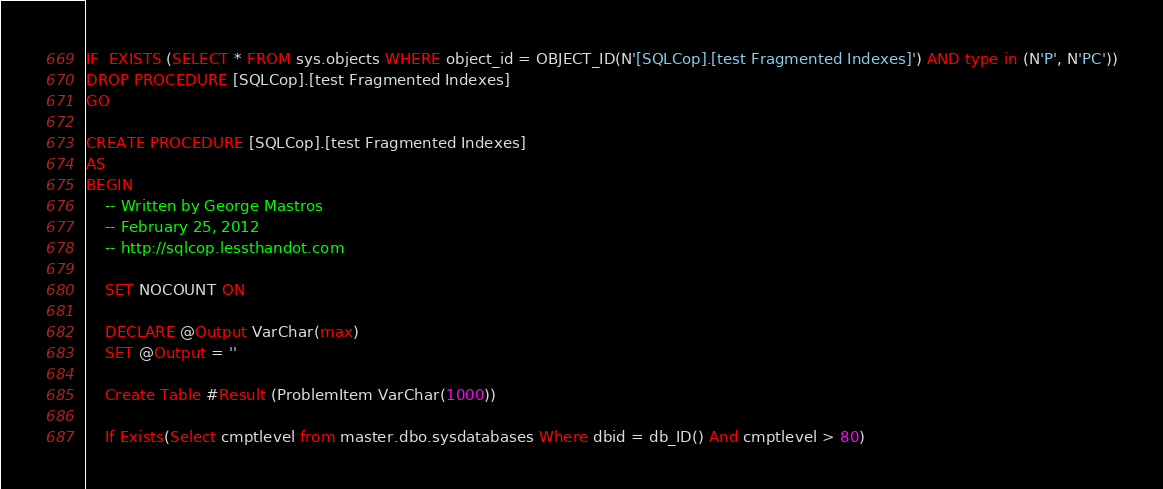Convert code to text. <code><loc_0><loc_0><loc_500><loc_500><_SQL_>IF  EXISTS (SELECT * FROM sys.objects WHERE object_id = OBJECT_ID(N'[SQLCop].[test Fragmented Indexes]') AND type in (N'P', N'PC'))
DROP PROCEDURE [SQLCop].[test Fragmented Indexes]
GO

CREATE PROCEDURE [SQLCop].[test Fragmented Indexes]
AS
BEGIN
	-- Written by George Mastros
	-- February 25, 2012
	-- http://sqlcop.lessthandot.com
	
	SET NOCOUNT ON
	
	DECLARE @Output VarChar(max)
	SET @Output = ''

	Create Table #Result (ProblemItem VarChar(1000))
	
	If Exists(Select cmptlevel from master.dbo.sysdatabases Where dbid = db_ID() And cmptlevel > 80)</code> 